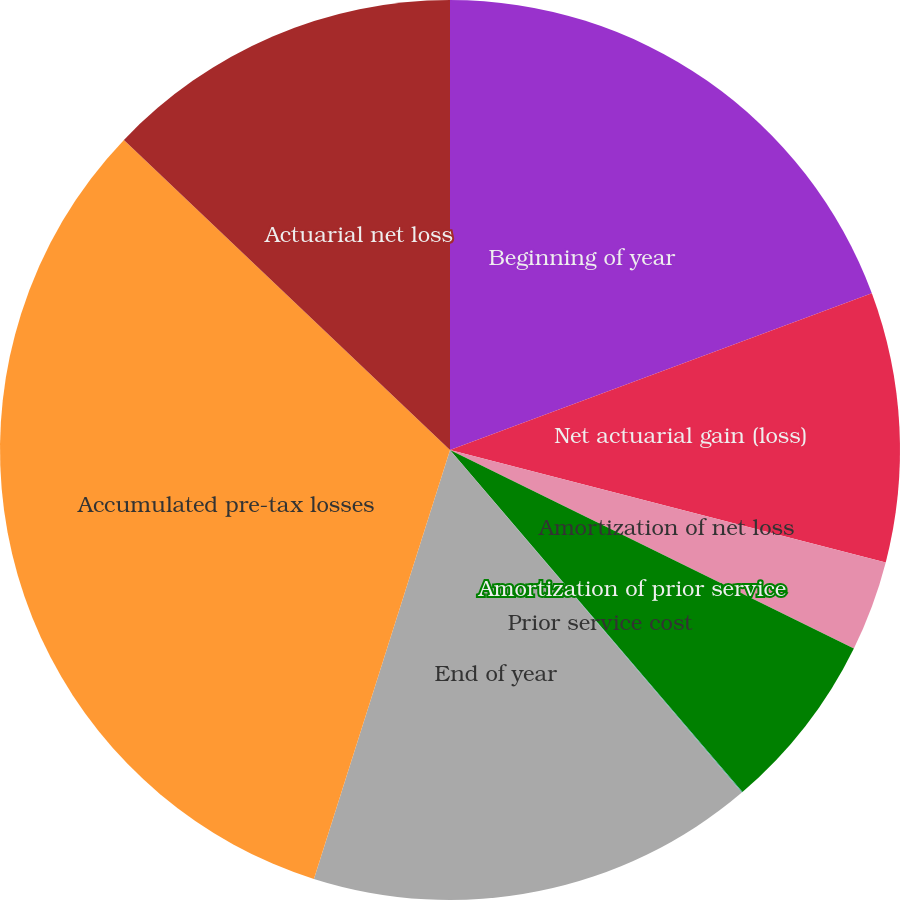Convert chart. <chart><loc_0><loc_0><loc_500><loc_500><pie_chart><fcel>Beginning of year<fcel>Net actuarial gain (loss)<fcel>Amortization of net loss<fcel>Amortization of prior service<fcel>Prior service cost<fcel>End of year<fcel>Accumulated pre-tax losses<fcel>Actuarial net loss<nl><fcel>19.34%<fcel>9.68%<fcel>3.25%<fcel>6.47%<fcel>0.03%<fcel>16.12%<fcel>32.21%<fcel>12.9%<nl></chart> 